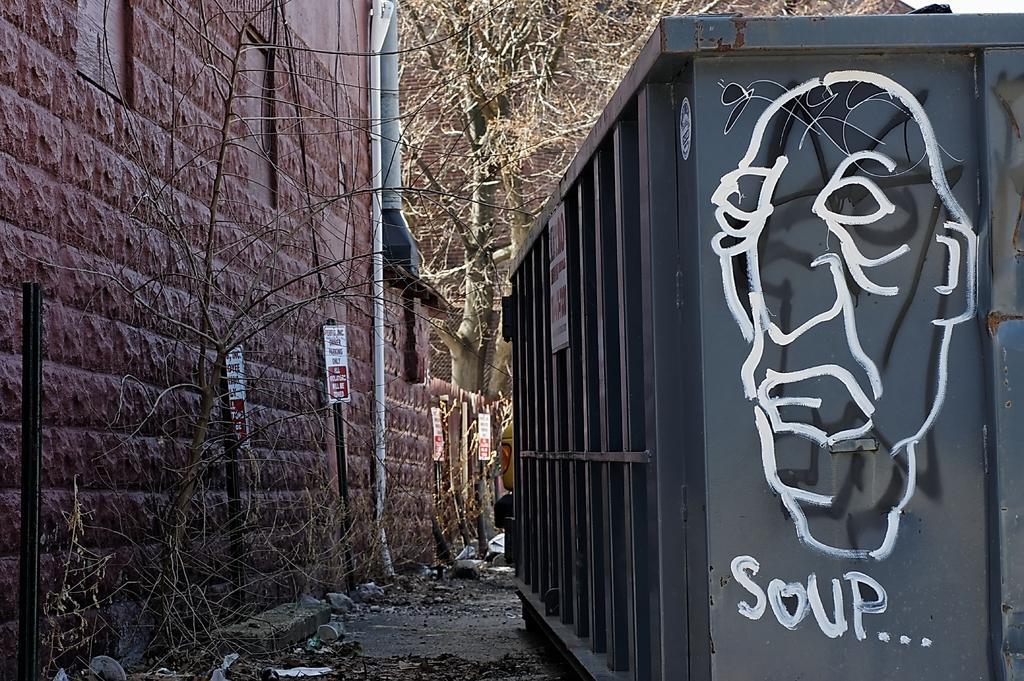What is located in the middle of the image? There is a container in the middle of the image. What can be seen behind the container? There are trees behind the container. What type of structure is visible in the image? There is fencing visible in the image. What other architectural feature can be seen in the image? There is a wall in the image. What type of pen does the writer use to create the image? There is no writer present in the image, and therefore no pen or writing instrument can be observed. 